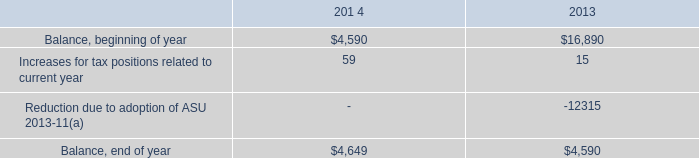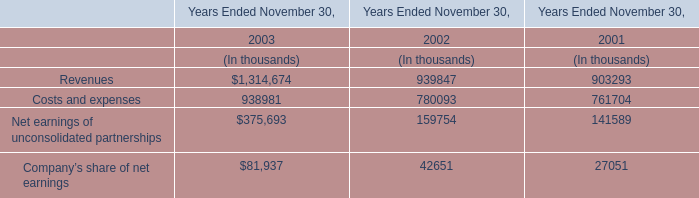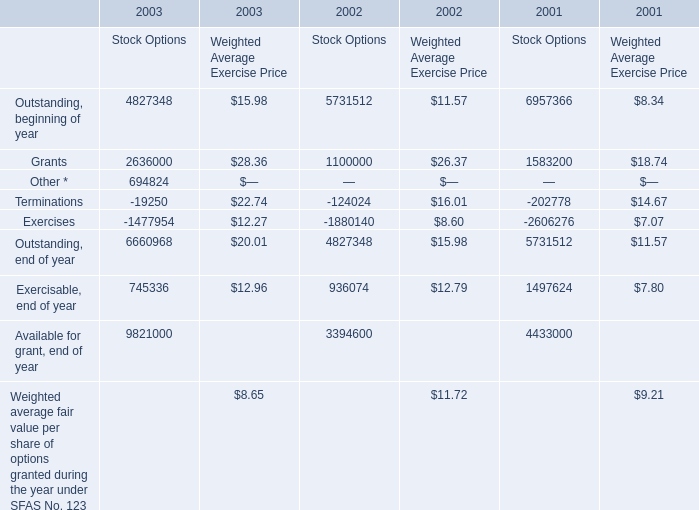Which year is Outstanding, beginning of year for Stock Options greater than 6000000 ? 
Answer: 2001. 